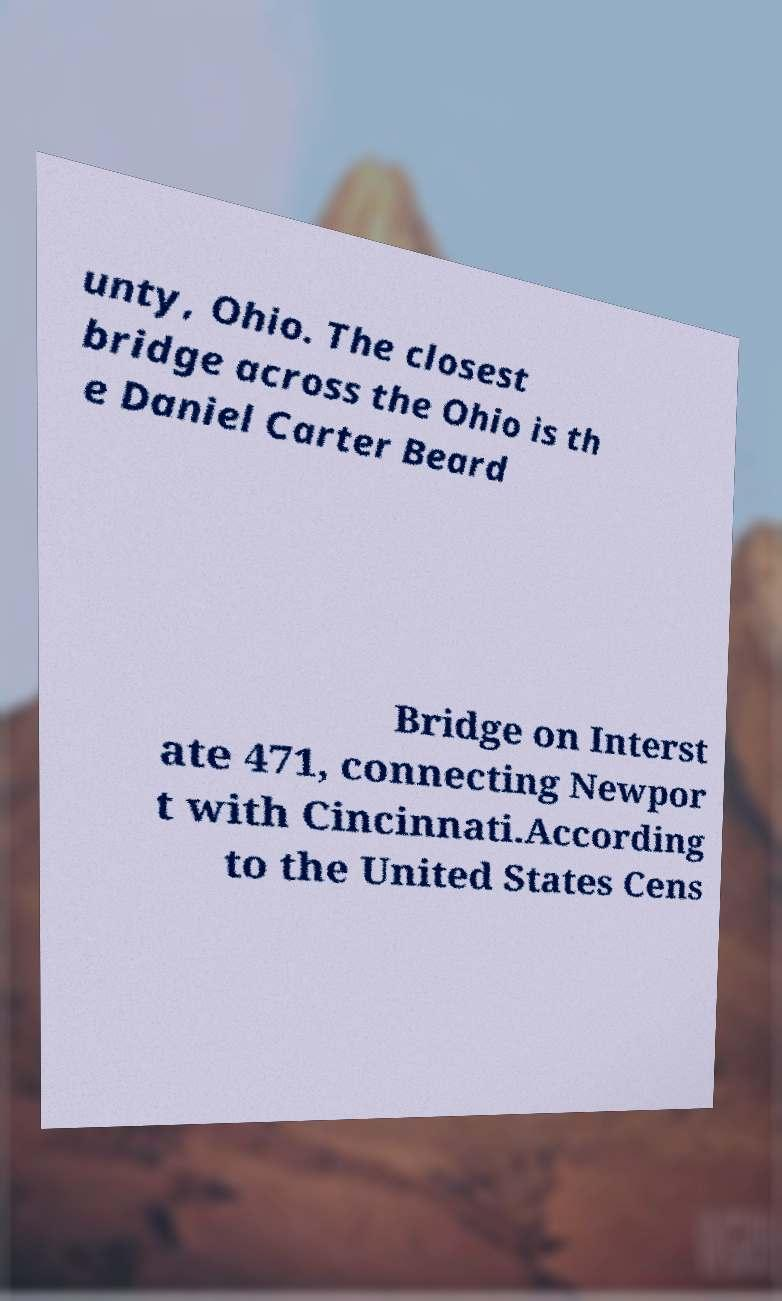For documentation purposes, I need the text within this image transcribed. Could you provide that? unty, Ohio. The closest bridge across the Ohio is th e Daniel Carter Beard Bridge on Interst ate 471, connecting Newpor t with Cincinnati.According to the United States Cens 